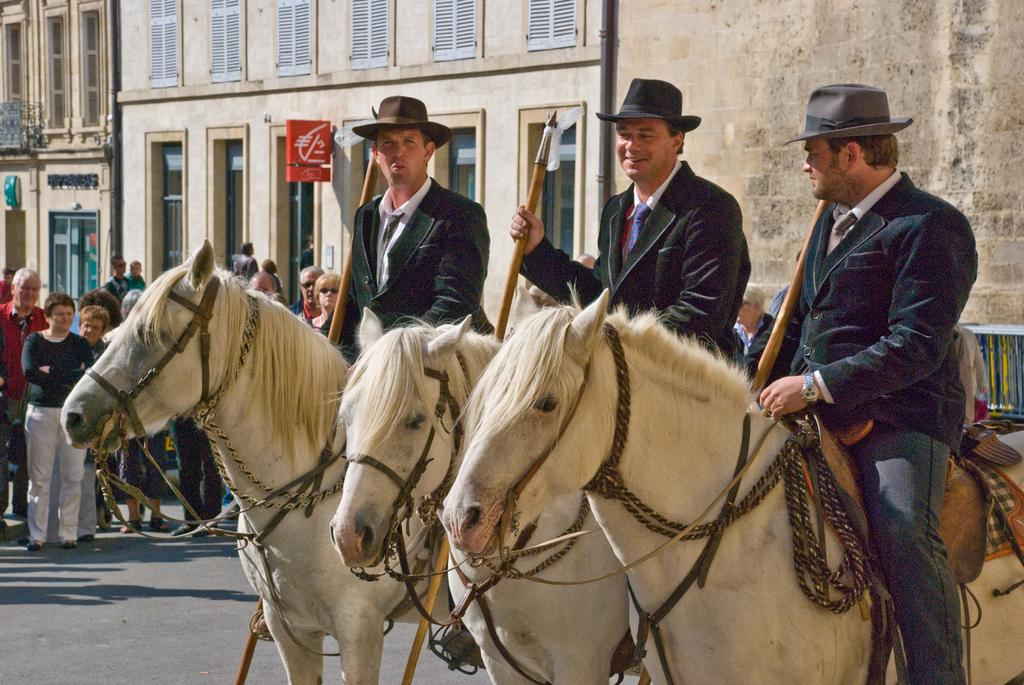How many men are in the image? There are three men in the image. What are the men doing in the image? The men are sitting on horses and holding sticks. What can be seen in the background of the image? There are people and buildings in the background of the image. What type of spoon is being used by the men in the image? There is no spoon present in the image; the men are holding sticks. How does the image show an increase in the number of people compared to the previous image? There is no information provided about a previous image, so we cannot determine if there is an increase in the number of people. 